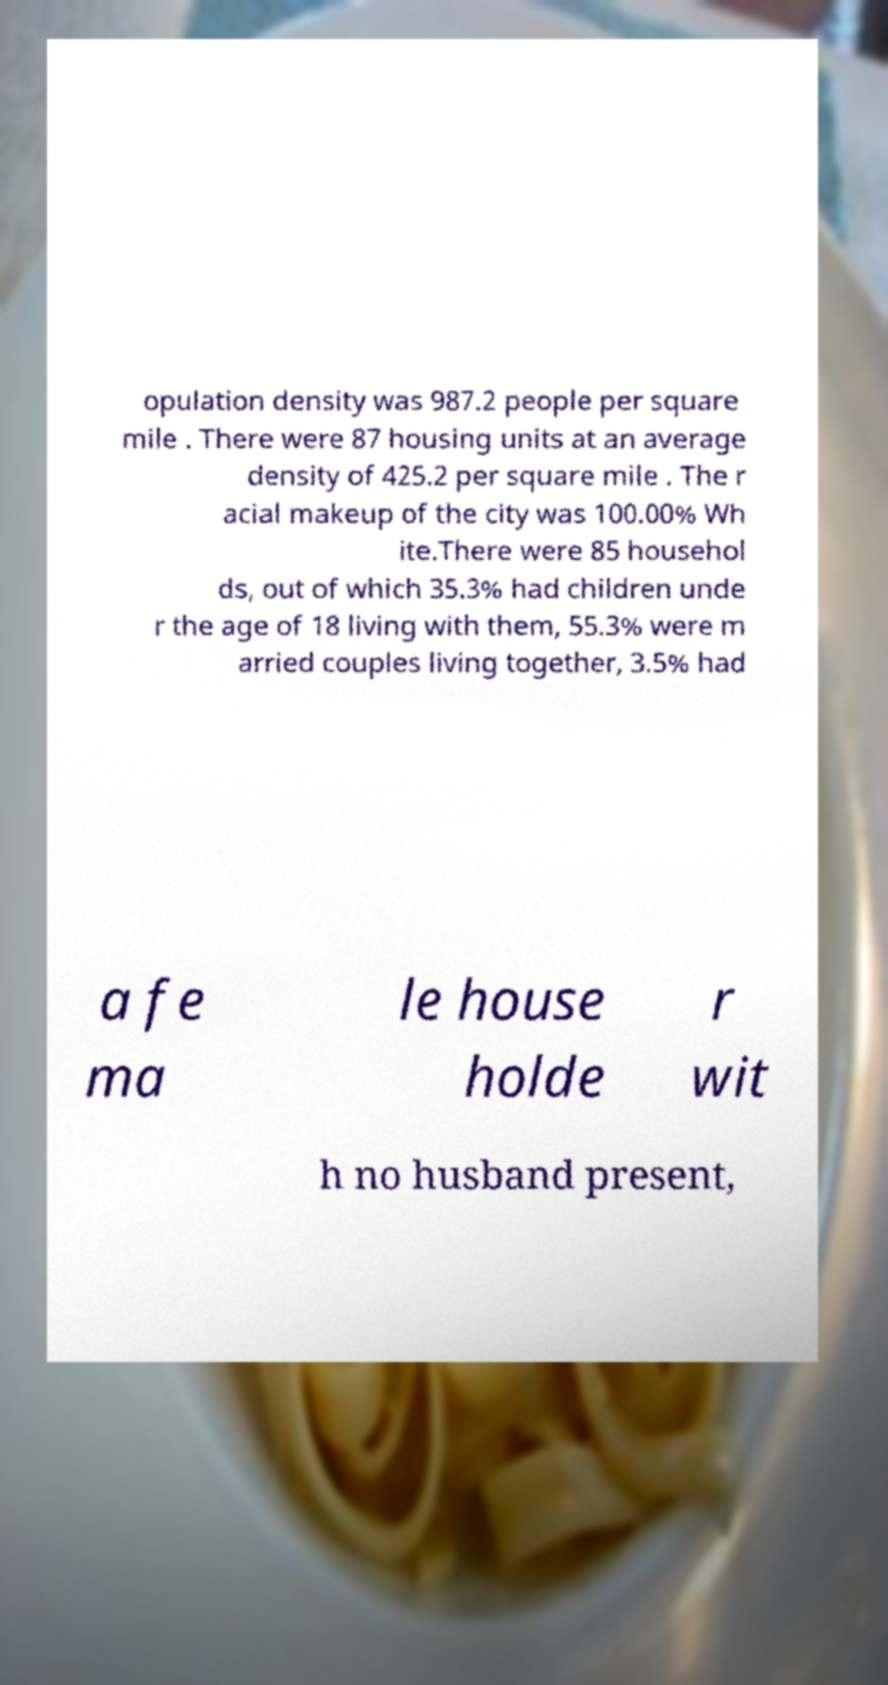Please read and relay the text visible in this image. What does it say? opulation density was 987.2 people per square mile . There were 87 housing units at an average density of 425.2 per square mile . The r acial makeup of the city was 100.00% Wh ite.There were 85 househol ds, out of which 35.3% had children unde r the age of 18 living with them, 55.3% were m arried couples living together, 3.5% had a fe ma le house holde r wit h no husband present, 